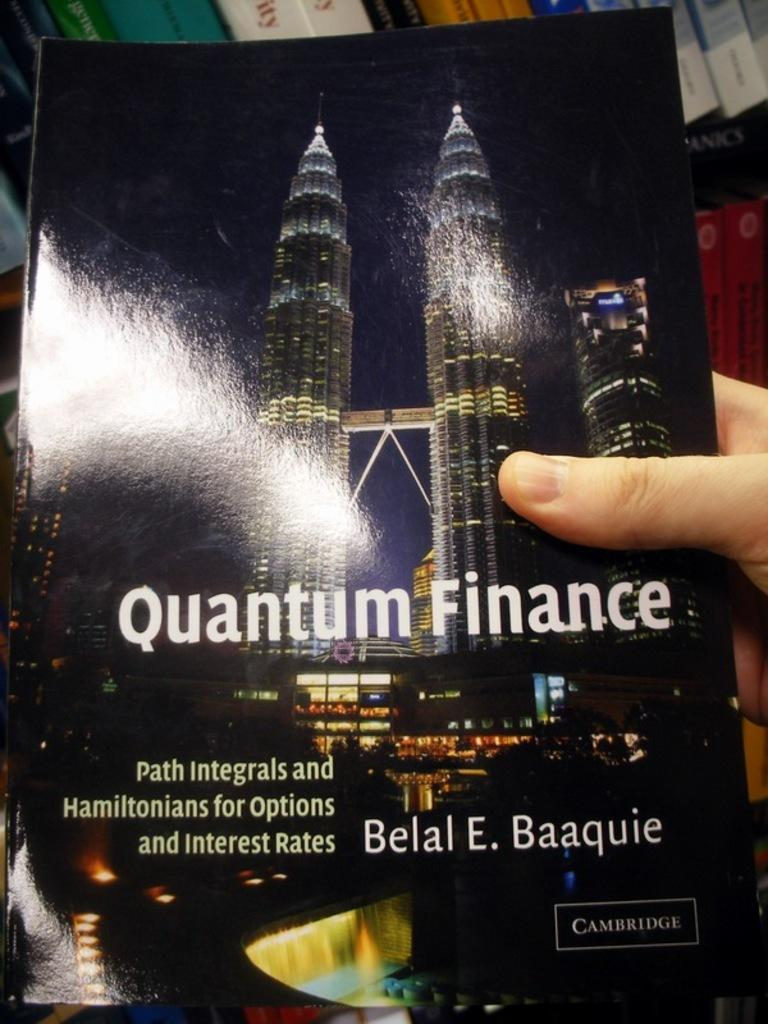<image>
Give a short and clear explanation of the subsequent image. a poster for Quantum Finance by Belal E. Baaquie 